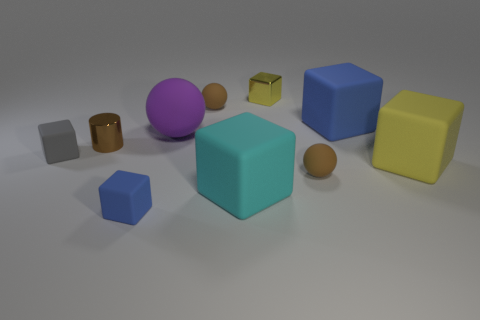Is the block that is behind the large blue thing made of the same material as the tiny brown cylinder? Based on the image, it's likely that both the block behind the large blue object and the tiny brown cylinder, despite differences in size and color, are made from a similar if not the same digital rendering material. Both exhibit a smooth texture and matte finish typical of objects created in a 3D modeling environment. 